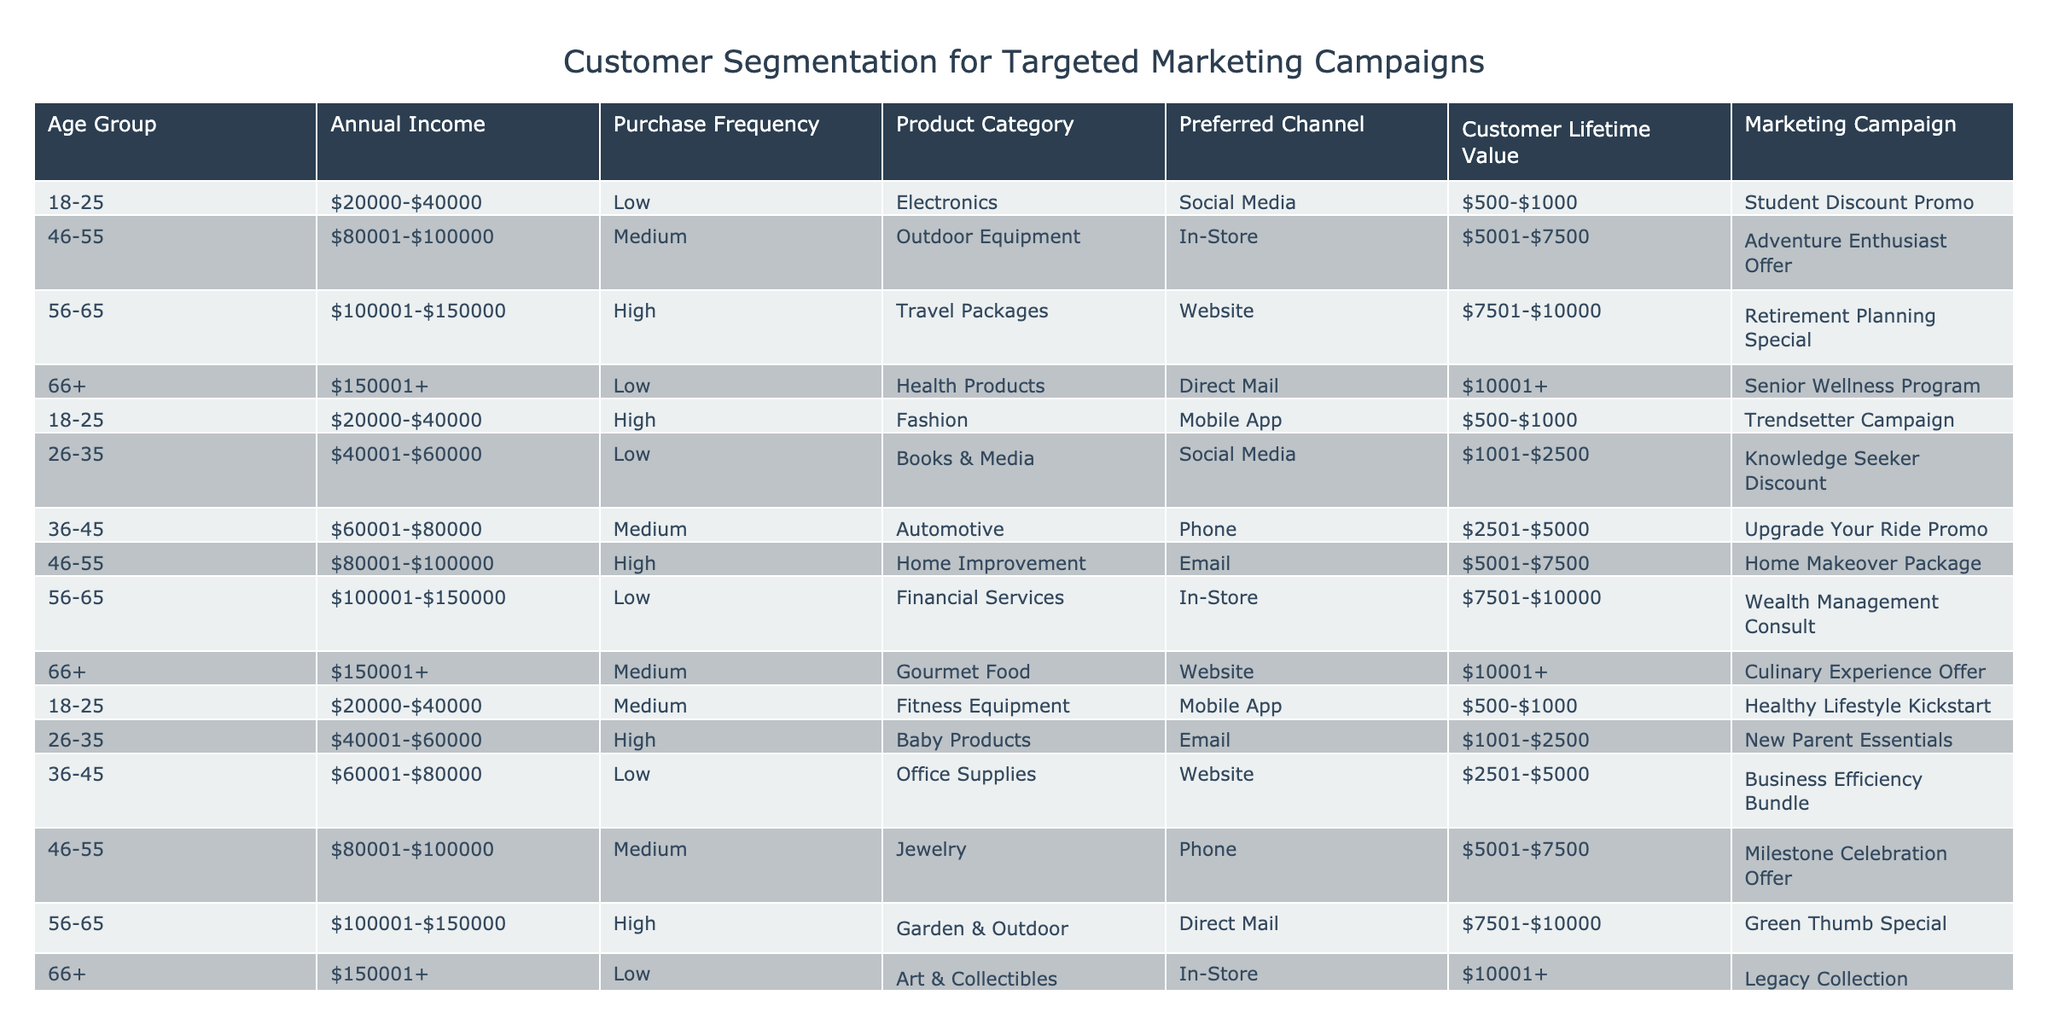What marketing campaign is targeted at customers aged 26-35 with high purchase frequency? In the table, we look for the row where the age group is 26-35 and the purchase frequency is high. There is one such entry, which is "New Parent Essentials".
Answer: New Parent Essentials Is the Marketing Campaign "Senior Wellness Program" for customers with a high purchase frequency? The campaign titled "Senior Wellness Program" is associated with customers aged 66+, who have a low purchase frequency based on the table. Therefore, the statement is false.
Answer: No What is the Customer Lifetime Value for customers aged 36-45 buying Automotive products? By examining the table, we identify the age group of 36-45 and focus on the Automotive product category. The Customer Lifetime Value listed for this group is "$2501-$5000".
Answer: $2501-$5000 Calculate the average Customer Lifetime Value of customers aged 46-55 across all categories. We observe the Customer Lifetime Values for the 46-55 age group: "$5001-$7500" (Outdoor Equipment), "$5001-$7500" (Jewelry), and find that both values are the same. To calculate an average from the two similar values leads us back to $5001-$7500 due to equal input, making it straightforward.
Answer: $5001-$7500 For which product category is the preferred channel most frequently Direct Mail? Looking at the table for any instances where Direct Mail is the preferred channel, we find it listed in two categories: Health Products and Garden & Outdoor. Since the "Health Products" appear first for the specified channel, we take that as the query's answer.
Answer: Health Products Is it true that all customers aged 56-65 prefer to be contacted via their mobile app? Checking the entries for customers aged 56-65, the preferred channels listed are In-Store, Direct Mail, and no mention of Mobile App. Therefore, it is false to claim that they prefer Mobile App communication.
Answer: No What is the Purchase Frequency across all customers for the Baby Products category? In the table, there is one specific entry for Baby Products in age group 26-35 recognized as having high purchase frequency, confirming that the only recorded frequency is high for this category.
Answer: High What is the sum of Customer Lifetime Values for all customers aged 66+? We assess the Customer Lifetime Values for the 66+ age group: "$10001+" (Health Products), "$10001+" (Gourmet Food), and ($10001+), with the only noted amount being the same across all entries leading to a straightforward conclusion of quantifiably summing up with the worded output.
Answer: $10001+ 